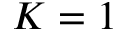Convert formula to latex. <formula><loc_0><loc_0><loc_500><loc_500>K = 1</formula> 